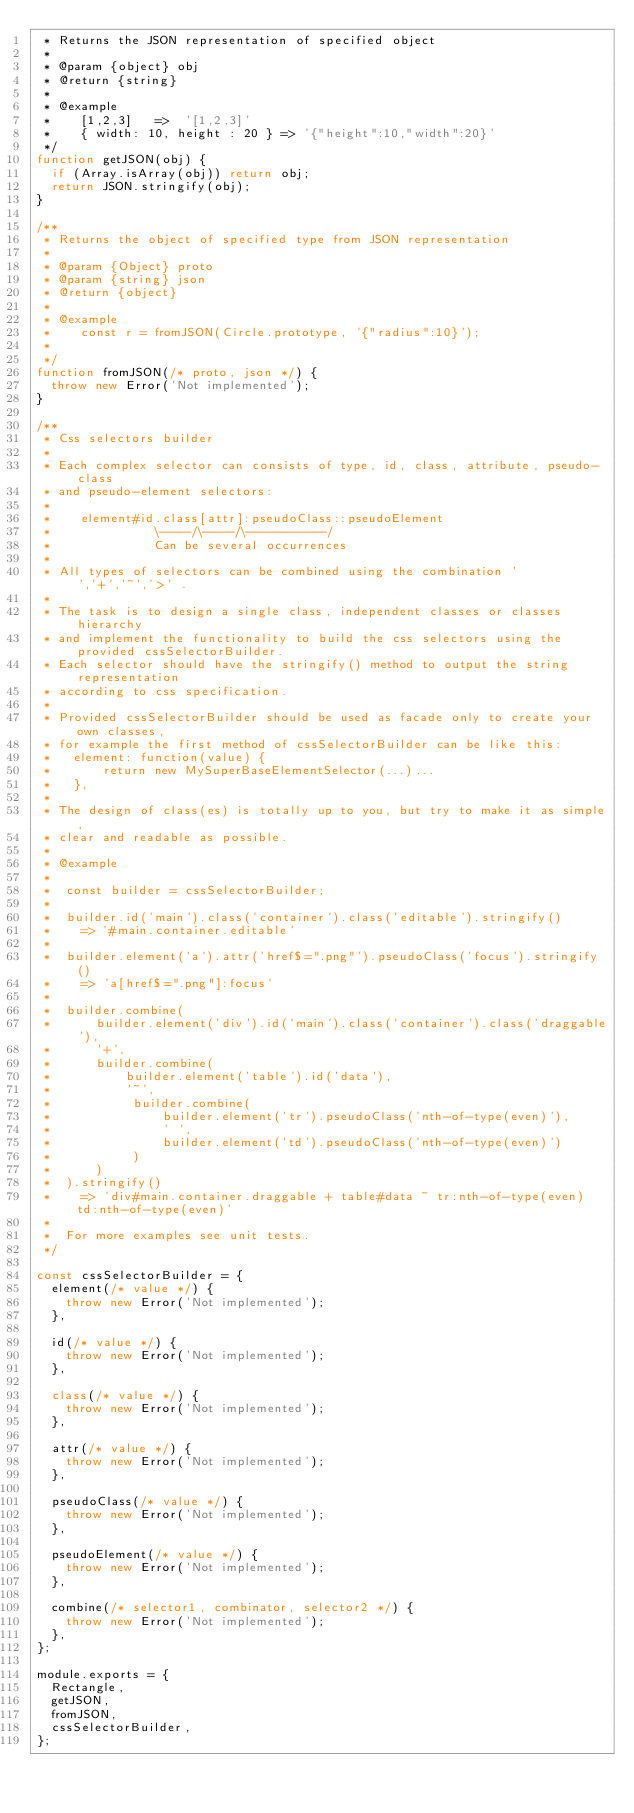Convert code to text. <code><loc_0><loc_0><loc_500><loc_500><_JavaScript_> * Returns the JSON representation of specified object
 *
 * @param {object} obj
 * @return {string}
 *
 * @example
 *    [1,2,3]   =>  '[1,2,3]'
 *    { width: 10, height : 20 } => '{"height":10,"width":20}'
 */
function getJSON(obj) {
  if (Array.isArray(obj)) return obj;
  return JSON.stringify(obj);
}

/**
 * Returns the object of specified type from JSON representation
 *
 * @param {Object} proto
 * @param {string} json
 * @return {object}
 *
 * @example
 *    const r = fromJSON(Circle.prototype, '{"radius":10}');
 *
 */
function fromJSON(/* proto, json */) {
  throw new Error('Not implemented');
}

/**
 * Css selectors builder
 *
 * Each complex selector can consists of type, id, class, attribute, pseudo-class
 * and pseudo-element selectors:
 *
 *    element#id.class[attr]:pseudoClass::pseudoElement
 *              \----/\----/\----------/
 *              Can be several occurrences
 *
 * All types of selectors can be combined using the combination ' ','+','~','>' .
 *
 * The task is to design a single class, independent classes or classes hierarchy
 * and implement the functionality to build the css selectors using the provided cssSelectorBuilder.
 * Each selector should have the stringify() method to output the string representation
 * according to css specification.
 *
 * Provided cssSelectorBuilder should be used as facade only to create your own classes,
 * for example the first method of cssSelectorBuilder can be like this:
 *   element: function(value) {
 *       return new MySuperBaseElementSelector(...)...
 *   },
 *
 * The design of class(es) is totally up to you, but try to make it as simple,
 * clear and readable as possible.
 *
 * @example
 *
 *  const builder = cssSelectorBuilder;
 *
 *  builder.id('main').class('container').class('editable').stringify()
 *    => '#main.container.editable'
 *
 *  builder.element('a').attr('href$=".png"').pseudoClass('focus').stringify()
 *    => 'a[href$=".png"]:focus'
 *
 *  builder.combine(
 *      builder.element('div').id('main').class('container').class('draggable'),
 *      '+',
 *      builder.combine(
 *          builder.element('table').id('data'),
 *          '~',
 *           builder.combine(
 *               builder.element('tr').pseudoClass('nth-of-type(even)'),
 *               ' ',
 *               builder.element('td').pseudoClass('nth-of-type(even)')
 *           )
 *      )
 *  ).stringify()
 *    => 'div#main.container.draggable + table#data ~ tr:nth-of-type(even)   td:nth-of-type(even)'
 *
 *  For more examples see unit tests.
 */

const cssSelectorBuilder = {
  element(/* value */) {
    throw new Error('Not implemented');
  },

  id(/* value */) {
    throw new Error('Not implemented');
  },

  class(/* value */) {
    throw new Error('Not implemented');
  },

  attr(/* value */) {
    throw new Error('Not implemented');
  },

  pseudoClass(/* value */) {
    throw new Error('Not implemented');
  },

  pseudoElement(/* value */) {
    throw new Error('Not implemented');
  },

  combine(/* selector1, combinator, selector2 */) {
    throw new Error('Not implemented');
  },
};

module.exports = {
  Rectangle,
  getJSON,
  fromJSON,
  cssSelectorBuilder,
};
</code> 